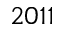Convert formula to latex. <formula><loc_0><loc_0><loc_500><loc_500>2 0 1 1</formula> 